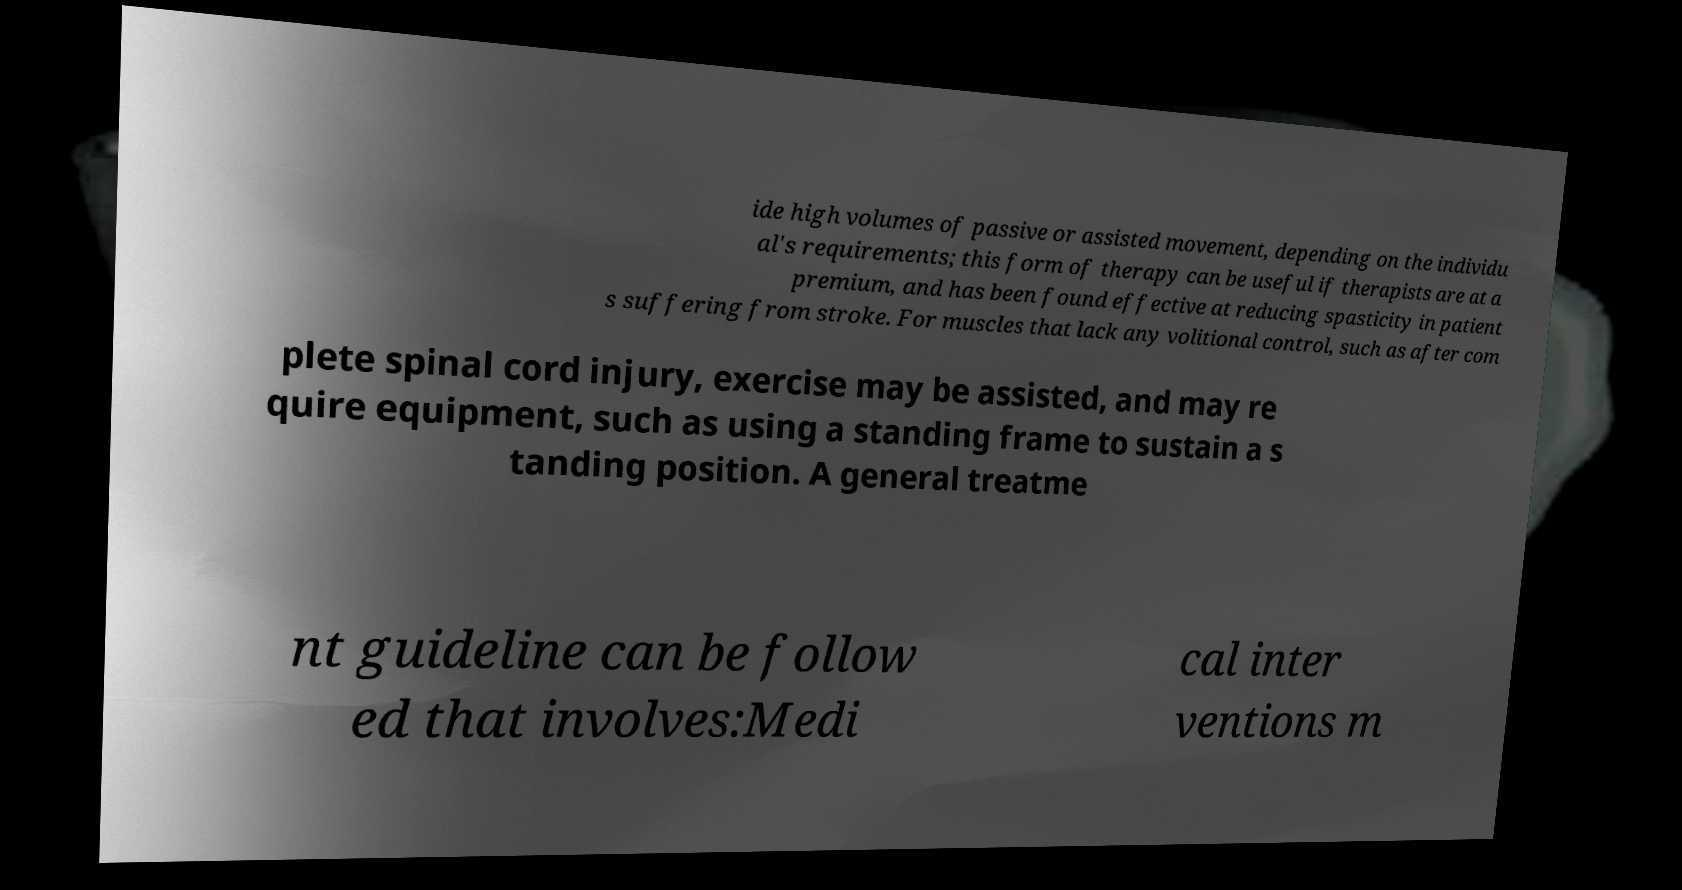What messages or text are displayed in this image? I need them in a readable, typed format. ide high volumes of passive or assisted movement, depending on the individu al's requirements; this form of therapy can be useful if therapists are at a premium, and has been found effective at reducing spasticity in patient s suffering from stroke. For muscles that lack any volitional control, such as after com plete spinal cord injury, exercise may be assisted, and may re quire equipment, such as using a standing frame to sustain a s tanding position. A general treatme nt guideline can be follow ed that involves:Medi cal inter ventions m 